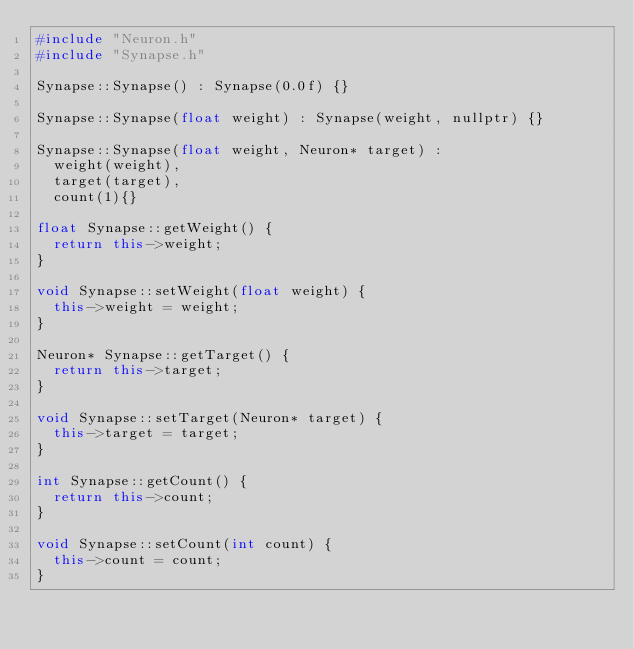Convert code to text. <code><loc_0><loc_0><loc_500><loc_500><_C++_>#include "Neuron.h"
#include "Synapse.h"

Synapse::Synapse() : Synapse(0.0f) {}

Synapse::Synapse(float weight) : Synapse(weight, nullptr) {}

Synapse::Synapse(float weight, Neuron* target) :
	weight(weight),
	target(target),
	count(1){}

float Synapse::getWeight() {
	return this->weight;
}

void Synapse::setWeight(float weight) {
	this->weight = weight;
}

Neuron* Synapse::getTarget() {
	return this->target;
}

void Synapse::setTarget(Neuron* target) {
	this->target = target;
}

int Synapse::getCount() {
	return this->count;
}

void Synapse::setCount(int count) {
	this->count = count;
}</code> 